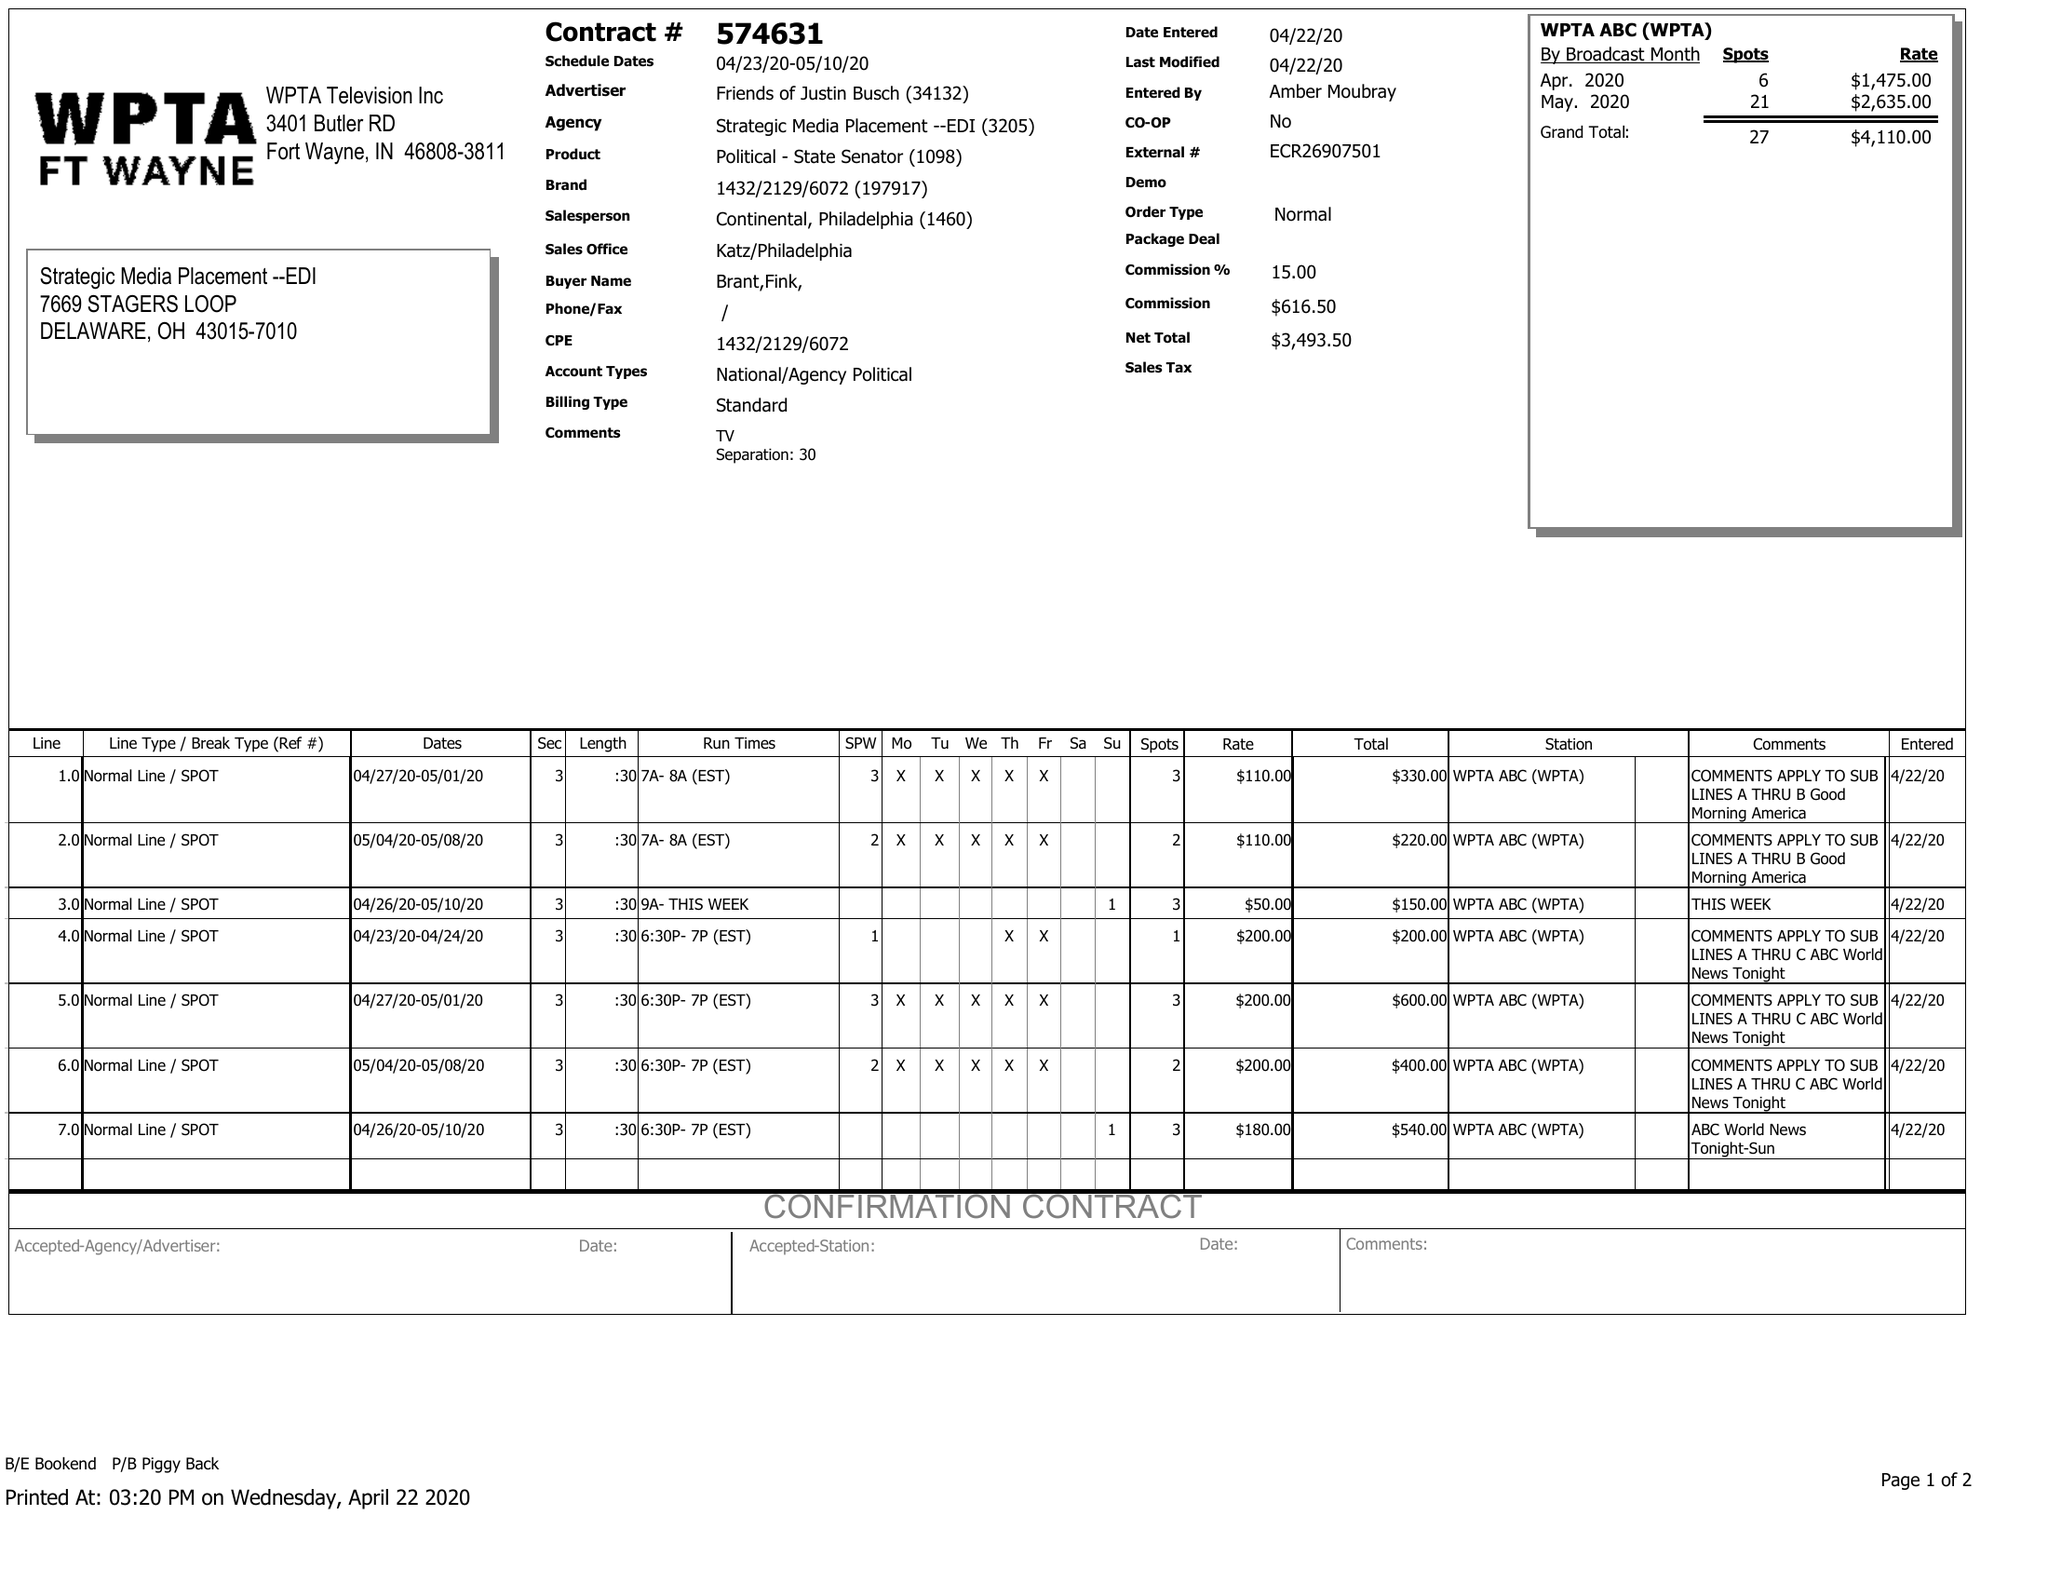What is the value for the flight_from?
Answer the question using a single word or phrase. 04/23/20 